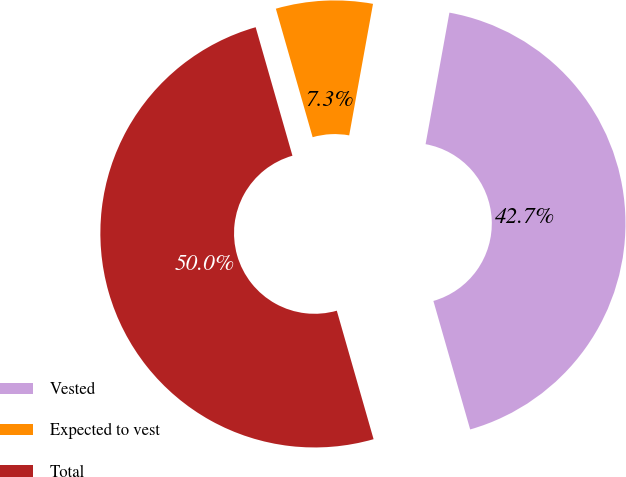Convert chart to OTSL. <chart><loc_0><loc_0><loc_500><loc_500><pie_chart><fcel>Vested<fcel>Expected to vest<fcel>Total<nl><fcel>42.71%<fcel>7.29%<fcel>50.0%<nl></chart> 